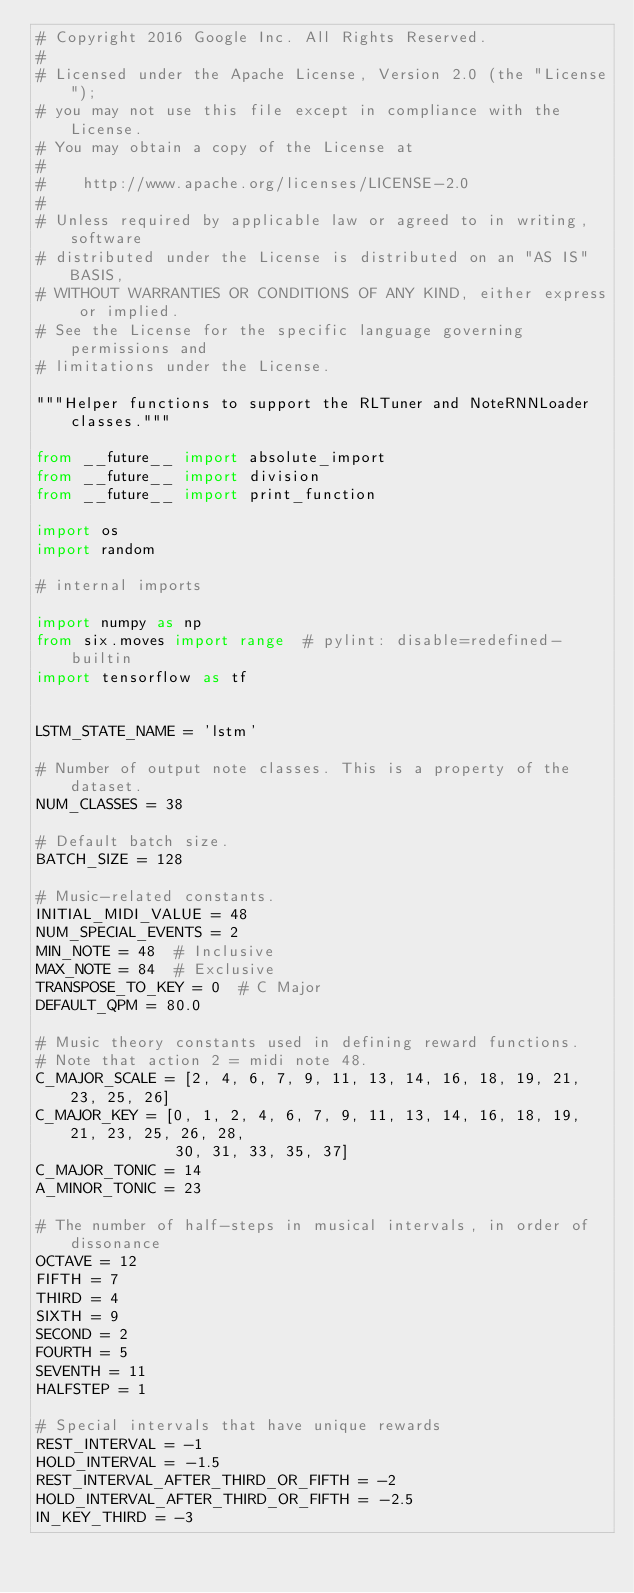<code> <loc_0><loc_0><loc_500><loc_500><_Python_># Copyright 2016 Google Inc. All Rights Reserved.
#
# Licensed under the Apache License, Version 2.0 (the "License");
# you may not use this file except in compliance with the License.
# You may obtain a copy of the License at
#
#    http://www.apache.org/licenses/LICENSE-2.0
#
# Unless required by applicable law or agreed to in writing, software
# distributed under the License is distributed on an "AS IS" BASIS,
# WITHOUT WARRANTIES OR CONDITIONS OF ANY KIND, either express or implied.
# See the License for the specific language governing permissions and
# limitations under the License.

"""Helper functions to support the RLTuner and NoteRNNLoader classes."""

from __future__ import absolute_import
from __future__ import division
from __future__ import print_function

import os
import random

# internal imports

import numpy as np
from six.moves import range  # pylint: disable=redefined-builtin
import tensorflow as tf


LSTM_STATE_NAME = 'lstm'

# Number of output note classes. This is a property of the dataset.
NUM_CLASSES = 38

# Default batch size.
BATCH_SIZE = 128

# Music-related constants.
INITIAL_MIDI_VALUE = 48
NUM_SPECIAL_EVENTS = 2
MIN_NOTE = 48  # Inclusive
MAX_NOTE = 84  # Exclusive
TRANSPOSE_TO_KEY = 0  # C Major
DEFAULT_QPM = 80.0

# Music theory constants used in defining reward functions.
# Note that action 2 = midi note 48.
C_MAJOR_SCALE = [2, 4, 6, 7, 9, 11, 13, 14, 16, 18, 19, 21, 23, 25, 26]
C_MAJOR_KEY = [0, 1, 2, 4, 6, 7, 9, 11, 13, 14, 16, 18, 19, 21, 23, 25, 26, 28,
               30, 31, 33, 35, 37]
C_MAJOR_TONIC = 14
A_MINOR_TONIC = 23

# The number of half-steps in musical intervals, in order of dissonance
OCTAVE = 12
FIFTH = 7
THIRD = 4
SIXTH = 9
SECOND = 2
FOURTH = 5
SEVENTH = 11
HALFSTEP = 1

# Special intervals that have unique rewards
REST_INTERVAL = -1
HOLD_INTERVAL = -1.5
REST_INTERVAL_AFTER_THIRD_OR_FIFTH = -2
HOLD_INTERVAL_AFTER_THIRD_OR_FIFTH = -2.5
IN_KEY_THIRD = -3</code> 